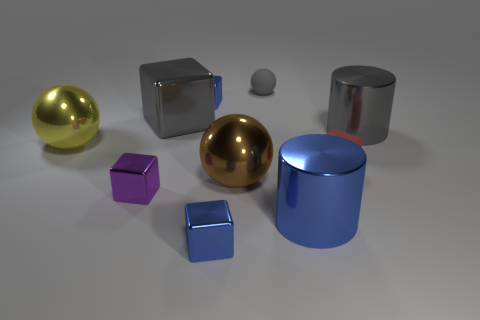Is there any other thing that is the same material as the large yellow object?
Give a very brief answer. Yes. What size is the other metallic thing that is the same shape as the large yellow thing?
Offer a terse response. Large. What color is the rubber thing that is the same shape as the large yellow shiny thing?
Provide a short and direct response. Gray. Does the tiny blue metal thing that is behind the large brown ball have the same shape as the small blue metallic thing that is in front of the brown ball?
Ensure brevity in your answer.  Yes. Do the brown metal sphere and the gray rubber ball have the same size?
Keep it short and to the point. No. There is a gray cylinder; is it the same size as the ball left of the tiny purple shiny thing?
Your answer should be compact. Yes. What number of objects are either gray metallic objects left of the brown object or big gray metal cubes that are on the left side of the gray cylinder?
Keep it short and to the point. 1. Is the number of metal spheres that are to the left of the purple metal object greater than the number of small blue matte things?
Make the answer very short. Yes. What number of other brown metal objects are the same size as the brown thing?
Keep it short and to the point. 0. Is the size of the gray metal thing on the right side of the small gray ball the same as the sphere that is to the left of the gray block?
Offer a terse response. Yes. 